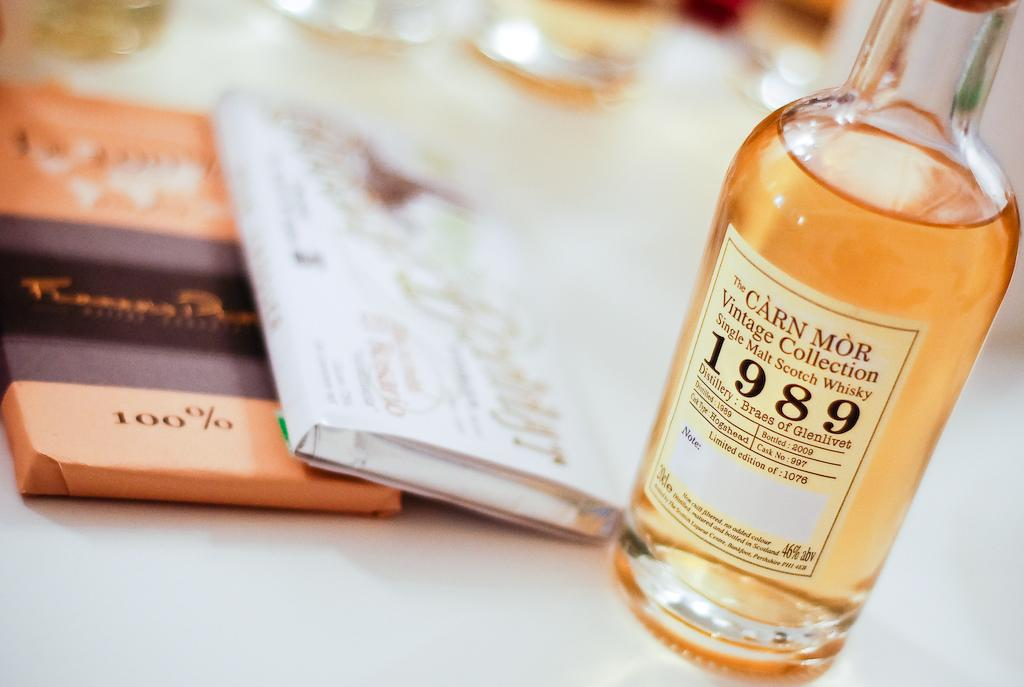<image>
Write a terse but informative summary of the picture. Chocolate Candy Bar with 100% on it behing a bottle of vintage 1989 Carn Mor 